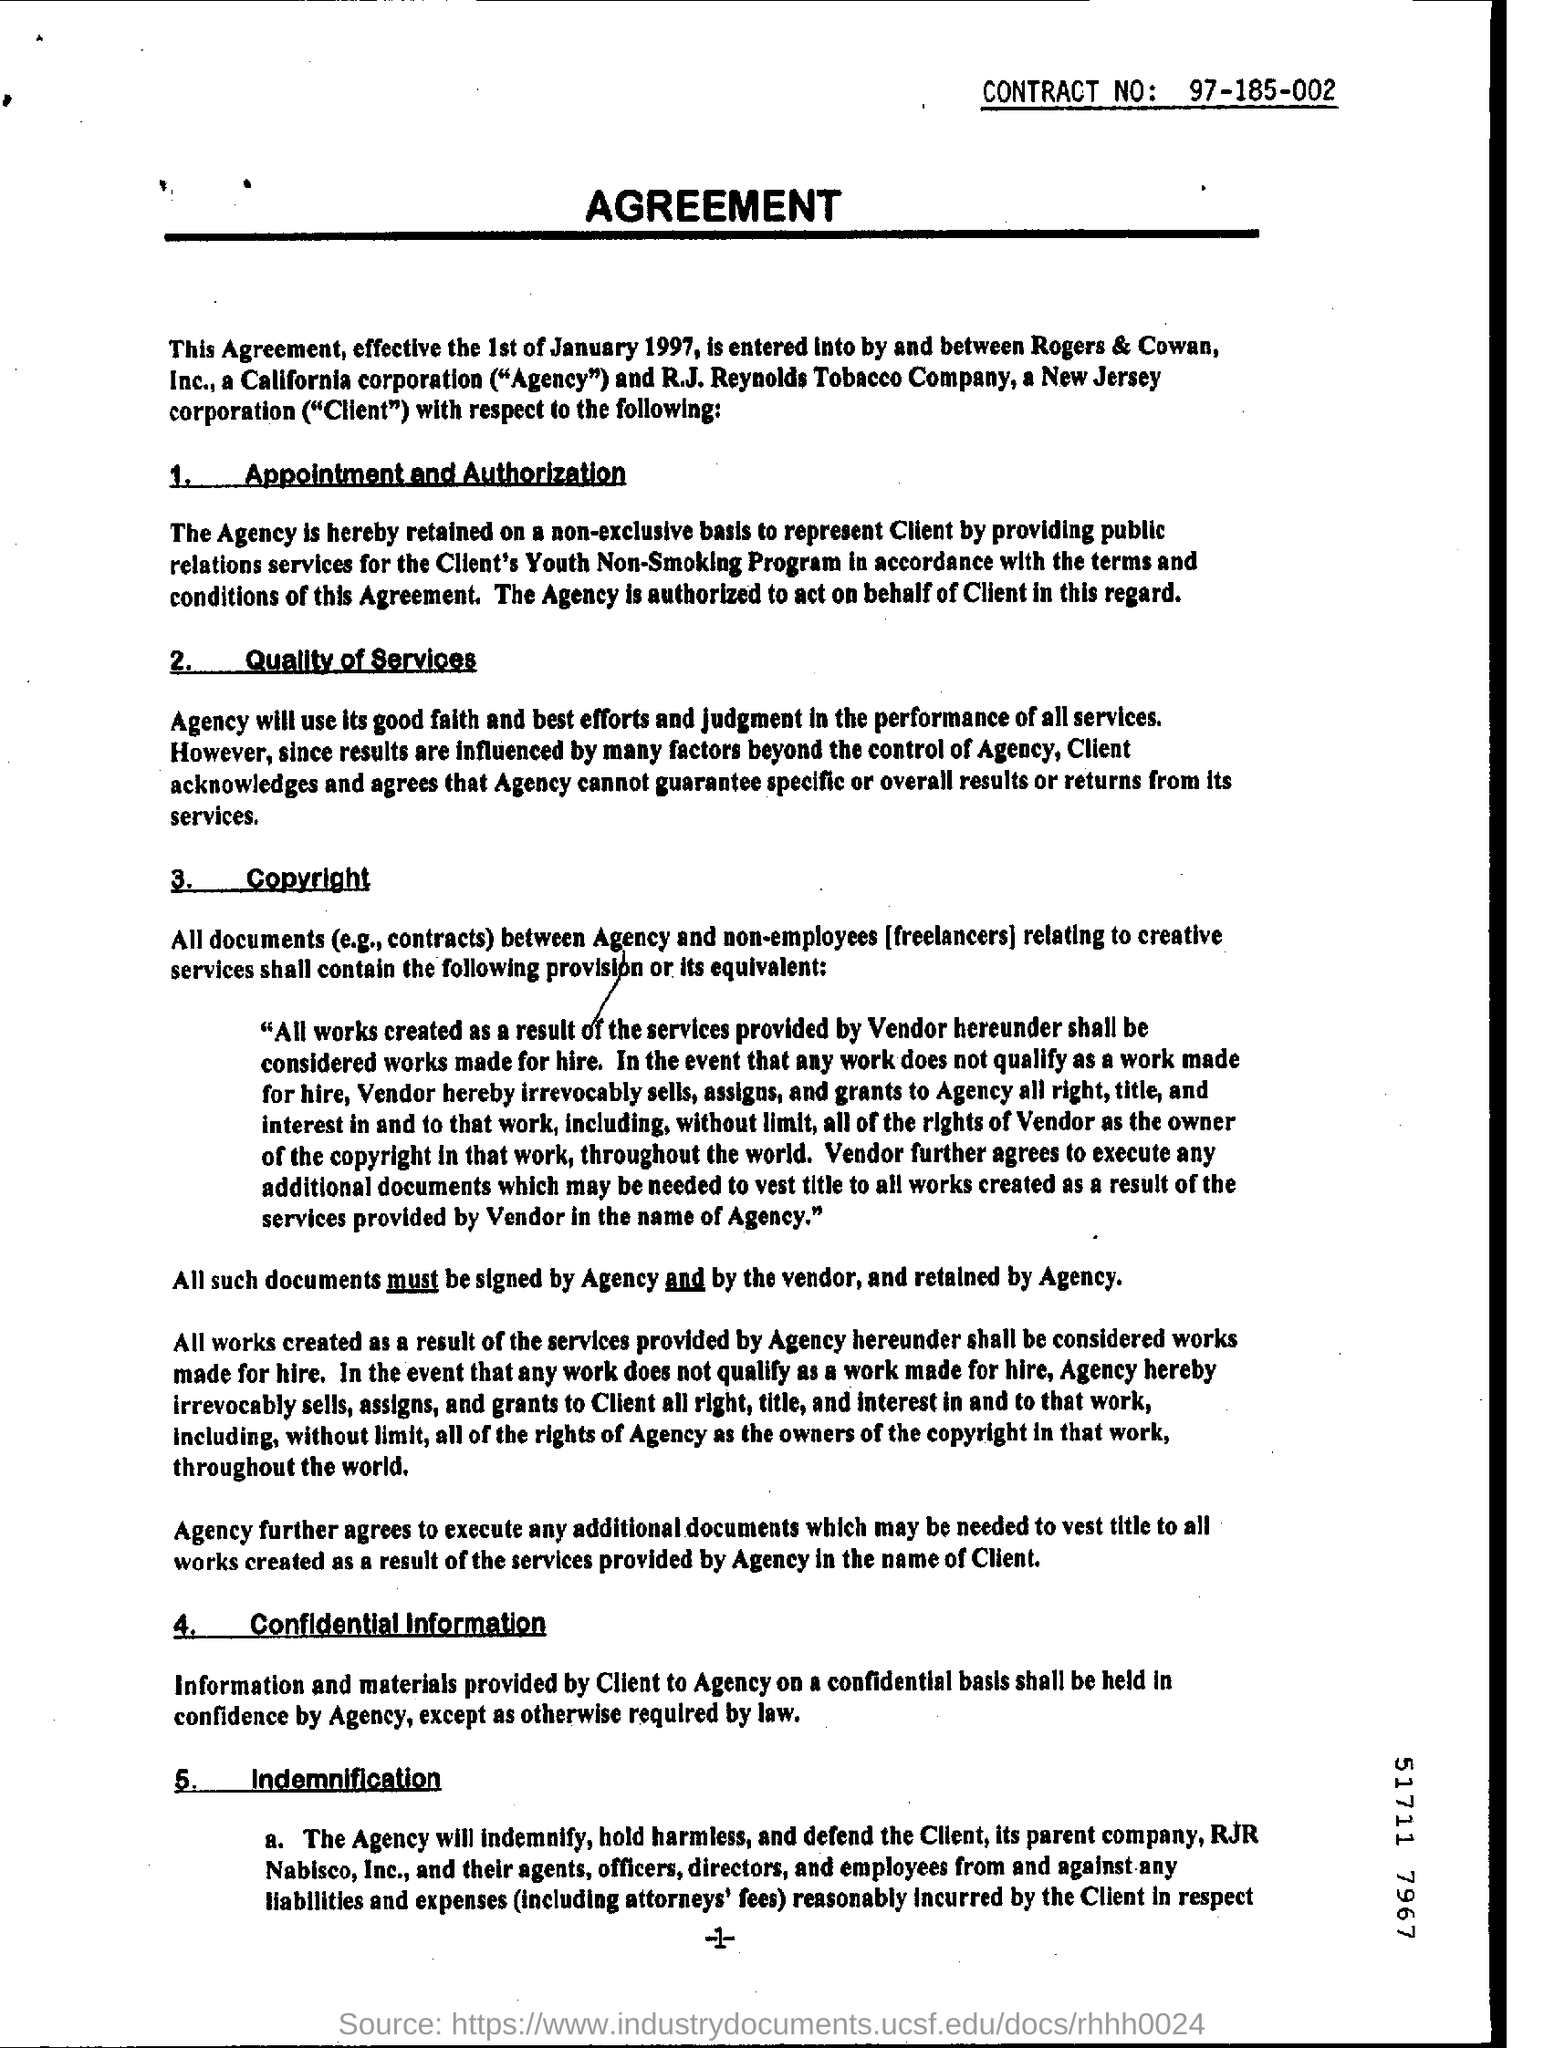What is the date mentioned in the first sentence?
Keep it short and to the point. 1st of January 1997. 